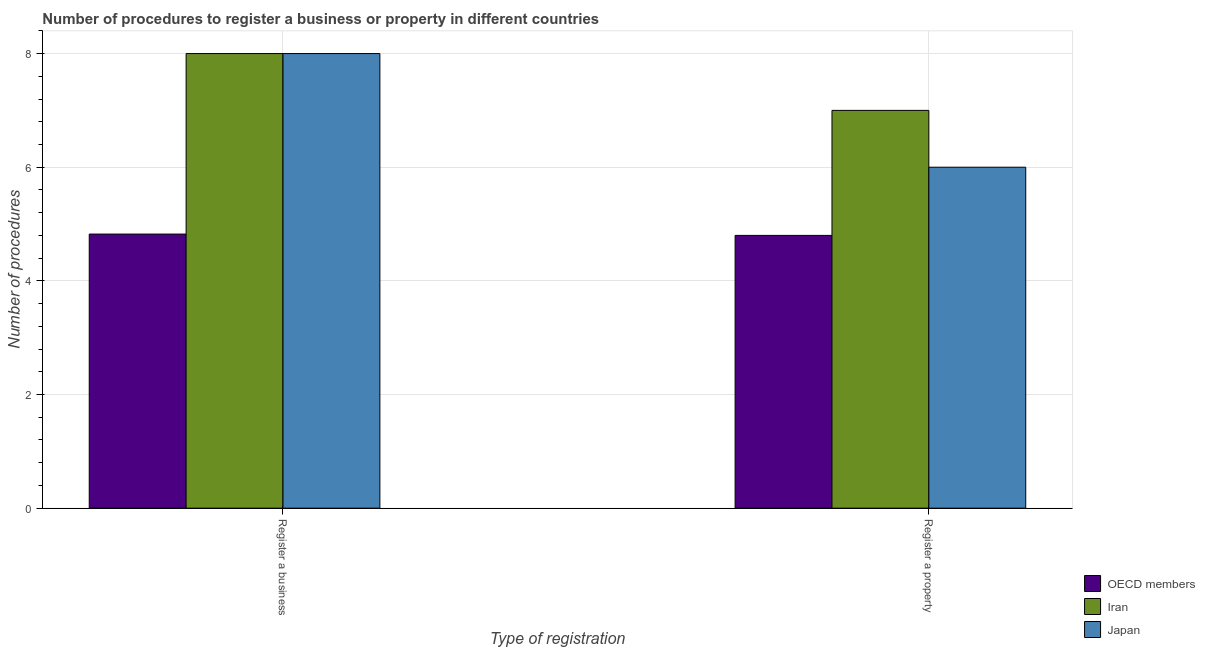How many groups of bars are there?
Keep it short and to the point. 2. Are the number of bars per tick equal to the number of legend labels?
Offer a very short reply. Yes. What is the label of the 1st group of bars from the left?
Offer a very short reply. Register a business. What is the number of procedures to register a business in Iran?
Keep it short and to the point. 8. Across all countries, what is the minimum number of procedures to register a business?
Provide a short and direct response. 4.82. In which country was the number of procedures to register a property maximum?
Offer a terse response. Iran. In which country was the number of procedures to register a property minimum?
Provide a succinct answer. OECD members. What is the total number of procedures to register a property in the graph?
Your response must be concise. 17.8. What is the difference between the number of procedures to register a property in Iran and the number of procedures to register a business in OECD members?
Provide a succinct answer. 2.18. What is the average number of procedures to register a business per country?
Offer a very short reply. 6.94. In how many countries, is the number of procedures to register a business greater than the average number of procedures to register a business taken over all countries?
Provide a short and direct response. 2. What does the 2nd bar from the left in Register a property represents?
Make the answer very short. Iran. What is the difference between two consecutive major ticks on the Y-axis?
Your response must be concise. 2. Are the values on the major ticks of Y-axis written in scientific E-notation?
Offer a very short reply. No. Does the graph contain grids?
Offer a very short reply. Yes. Where does the legend appear in the graph?
Provide a short and direct response. Bottom right. What is the title of the graph?
Provide a succinct answer. Number of procedures to register a business or property in different countries. What is the label or title of the X-axis?
Make the answer very short. Type of registration. What is the label or title of the Y-axis?
Your answer should be very brief. Number of procedures. What is the Number of procedures of OECD members in Register a business?
Provide a short and direct response. 4.82. What is the Number of procedures in Iran in Register a business?
Give a very brief answer. 8. What is the Number of procedures of Japan in Register a business?
Ensure brevity in your answer.  8. Across all Type of registration, what is the maximum Number of procedures of OECD members?
Ensure brevity in your answer.  4.82. Across all Type of registration, what is the maximum Number of procedures of Iran?
Your answer should be compact. 8. Across all Type of registration, what is the maximum Number of procedures of Japan?
Provide a short and direct response. 8. Across all Type of registration, what is the minimum Number of procedures of OECD members?
Provide a succinct answer. 4.8. Across all Type of registration, what is the minimum Number of procedures of Iran?
Offer a very short reply. 7. What is the total Number of procedures of OECD members in the graph?
Your answer should be very brief. 9.62. What is the total Number of procedures of Iran in the graph?
Offer a very short reply. 15. What is the difference between the Number of procedures of OECD members in Register a business and that in Register a property?
Offer a very short reply. 0.02. What is the difference between the Number of procedures of Japan in Register a business and that in Register a property?
Give a very brief answer. 2. What is the difference between the Number of procedures in OECD members in Register a business and the Number of procedures in Iran in Register a property?
Provide a short and direct response. -2.18. What is the difference between the Number of procedures of OECD members in Register a business and the Number of procedures of Japan in Register a property?
Offer a terse response. -1.18. What is the average Number of procedures of OECD members per Type of registration?
Provide a short and direct response. 4.81. What is the difference between the Number of procedures of OECD members and Number of procedures of Iran in Register a business?
Offer a terse response. -3.18. What is the difference between the Number of procedures in OECD members and Number of procedures in Japan in Register a business?
Your response must be concise. -3.18. What is the difference between the Number of procedures of Iran and Number of procedures of Japan in Register a business?
Provide a succinct answer. 0. What is the ratio of the Number of procedures of Iran in Register a business to that in Register a property?
Your answer should be very brief. 1.14. What is the ratio of the Number of procedures in Japan in Register a business to that in Register a property?
Offer a terse response. 1.33. What is the difference between the highest and the second highest Number of procedures of OECD members?
Your answer should be very brief. 0.02. What is the difference between the highest and the second highest Number of procedures in Iran?
Offer a terse response. 1. What is the difference between the highest and the second highest Number of procedures in Japan?
Keep it short and to the point. 2. What is the difference between the highest and the lowest Number of procedures in OECD members?
Your response must be concise. 0.02. What is the difference between the highest and the lowest Number of procedures in Japan?
Give a very brief answer. 2. 